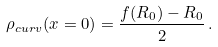Convert formula to latex. <formula><loc_0><loc_0><loc_500><loc_500>\rho _ { c u r v } ( x = 0 ) = \frac { f ( R _ { 0 } ) - R _ { 0 } } { 2 } \, .</formula> 